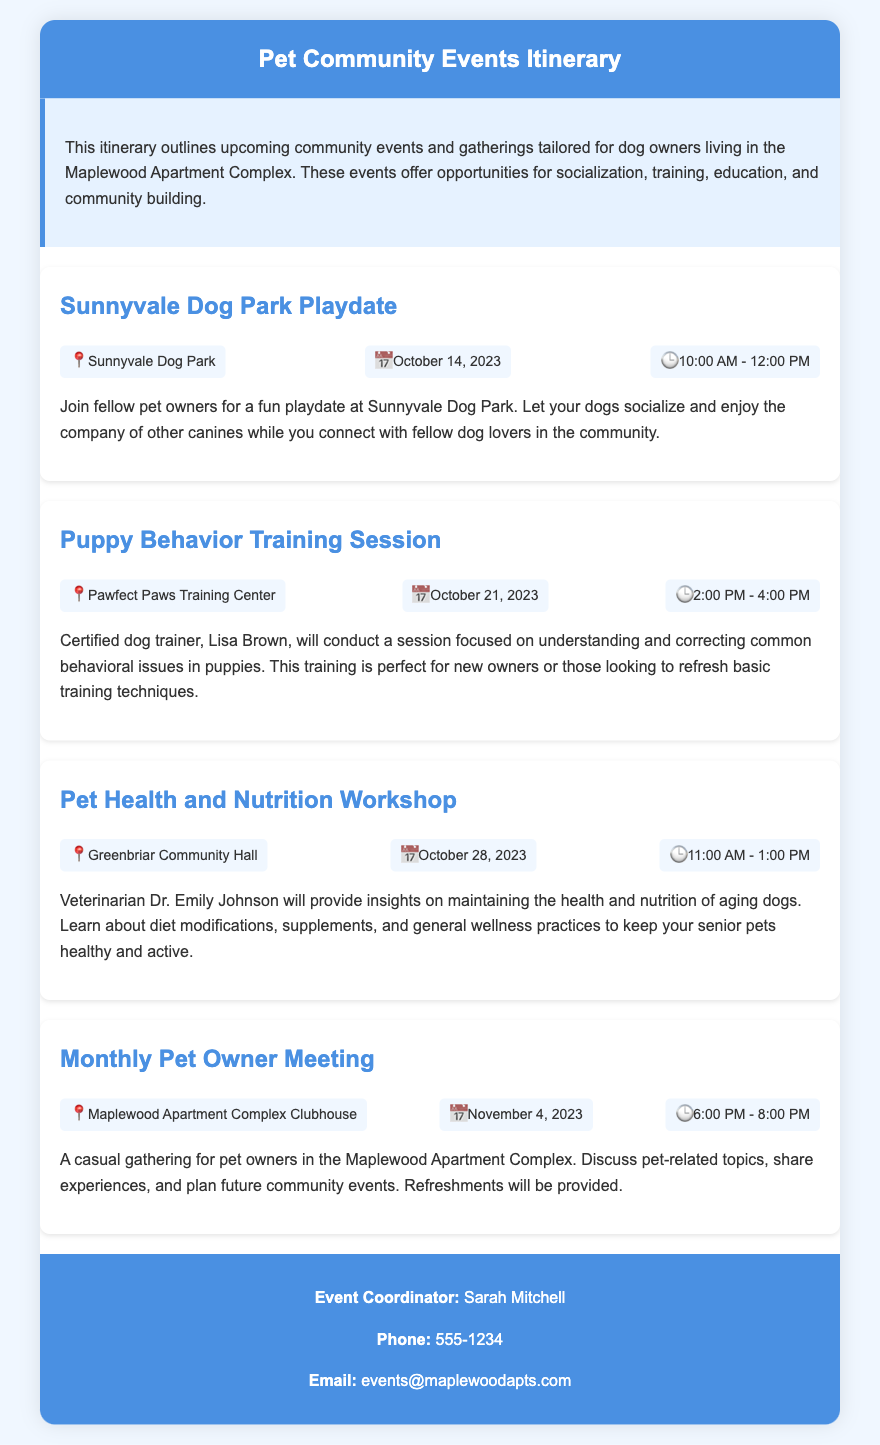What is the date of the Sunnyvale Dog Park Playdate? The date is specifically mentioned in the event details of the Sunnyvale Dog Park Playdate.
Answer: October 14, 2023 Who is the certified dog trainer for the Puppy Behavior Training Session? The document states the name of the trainer conducting the session, which is included in the event description.
Answer: Lisa Brown What location is the Monthly Pet Owner Meeting held? The location is stated under the event details for the Monthly Pet Owner Meeting.
Answer: Maplewood Apartment Complex Clubhouse What time does the Pet Health and Nutrition Workshop start? The start time is provided in the event details of the Pet Health and Nutrition Workshop.
Answer: 11:00 AM How many community events are listed in the itinerary? The total number of events is counted based on the number of event sections in the document.
Answer: Four What type of insights will Dr. Emily Johnson provide in the workshop? The insights are explicitly described in the event details for the Pet Health and Nutrition Workshop.
Answer: Health and nutrition of aging dogs When will the Puppy Behavior Training Session occur? The specific date for the session is detailed under the event details for that training session.
Answer: October 21, 2023 What is the purpose of the Monthly Pet Owner Meeting? The purpose of the meeting is outlined in the description portion of that event.
Answer: Discuss pet-related topics What is the contact phone number for the event coordinator? The phone number is displayed in the contact information section of the document.
Answer: 555-1234 